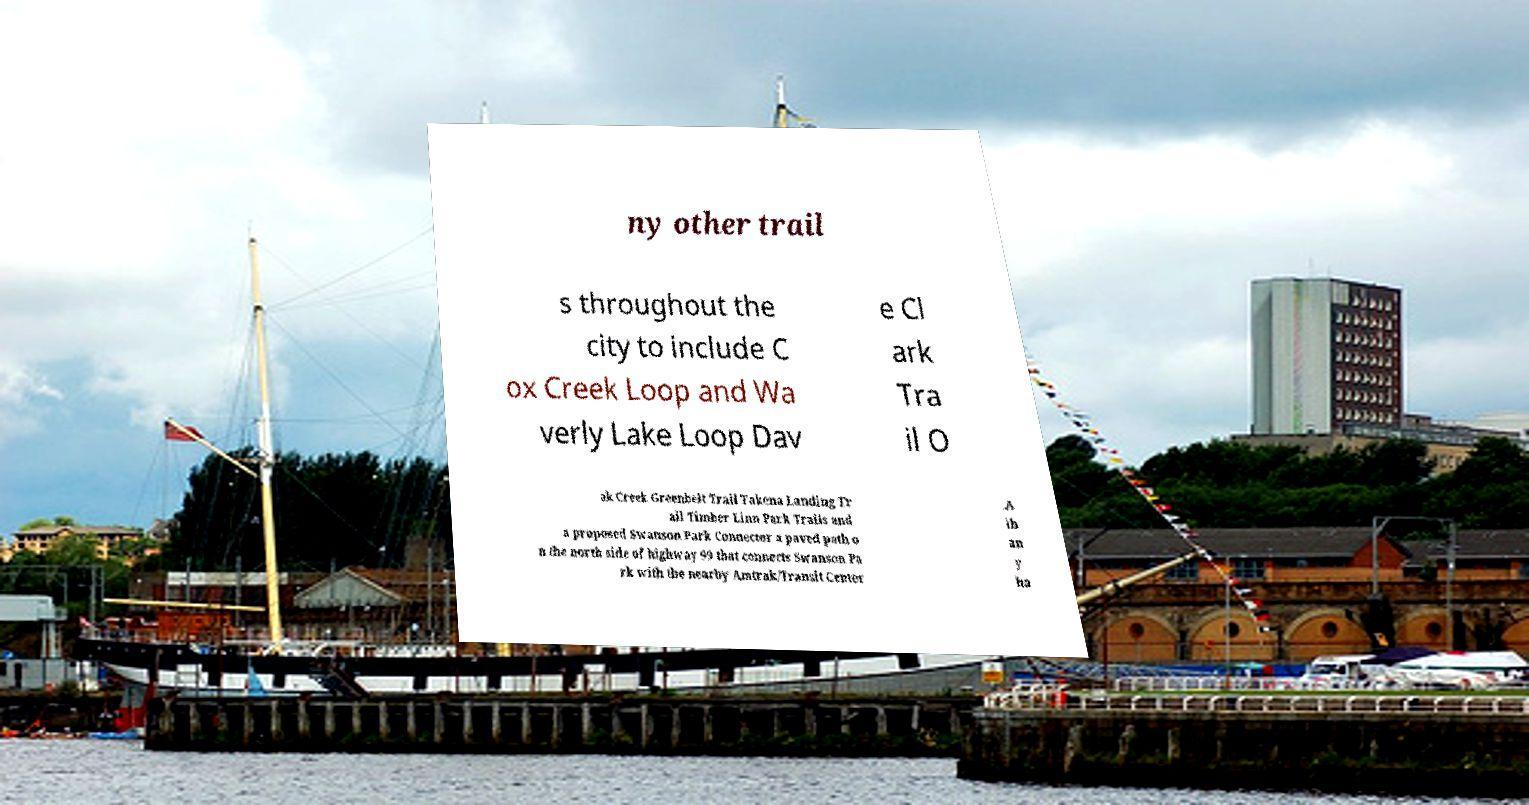Can you accurately transcribe the text from the provided image for me? ny other trail s throughout the city to include C ox Creek Loop and Wa verly Lake Loop Dav e Cl ark Tra il O ak Creek Greenbelt Trail Takena Landing Tr ail Timber Linn Park Trails and a proposed Swanson Park Connector a paved path o n the north side of highway 99 that connects Swanson Pa rk with the nearby Amtrak/Transit Center .A lb an y ha 